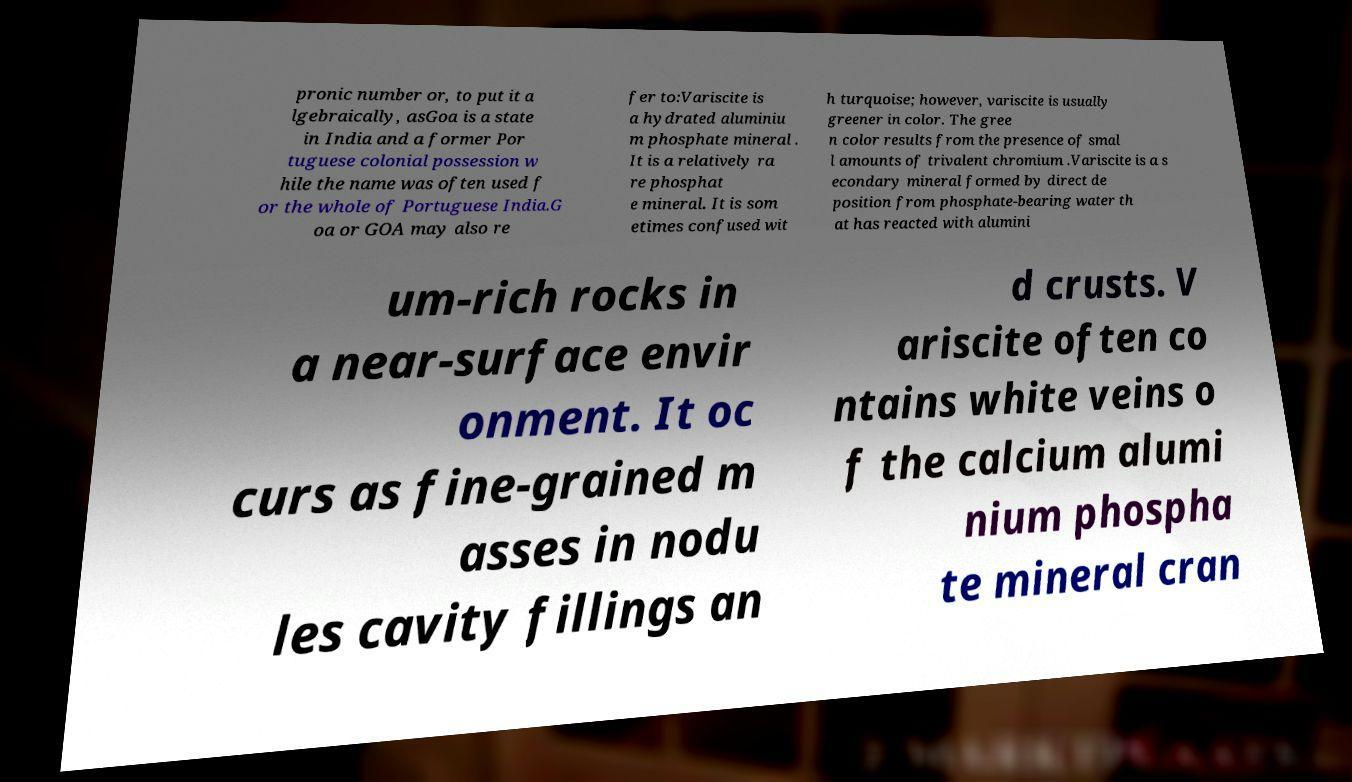For documentation purposes, I need the text within this image transcribed. Could you provide that? pronic number or, to put it a lgebraically, asGoa is a state in India and a former Por tuguese colonial possession w hile the name was often used f or the whole of Portuguese India.G oa or GOA may also re fer to:Variscite is a hydrated aluminiu m phosphate mineral . It is a relatively ra re phosphat e mineral. It is som etimes confused wit h turquoise; however, variscite is usually greener in color. The gree n color results from the presence of smal l amounts of trivalent chromium .Variscite is a s econdary mineral formed by direct de position from phosphate-bearing water th at has reacted with alumini um-rich rocks in a near-surface envir onment. It oc curs as fine-grained m asses in nodu les cavity fillings an d crusts. V ariscite often co ntains white veins o f the calcium alumi nium phospha te mineral cran 